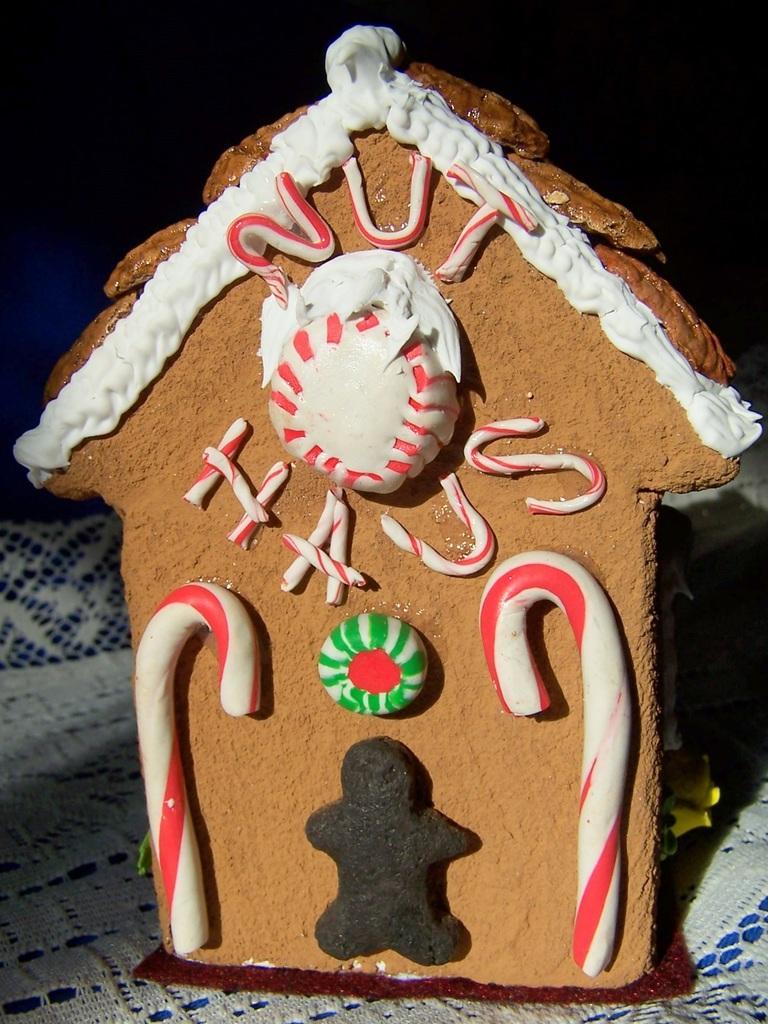Please provide a concise description of this image. Here we can see a cookie in the shape of a house. On this cookie we can see candies and there is a dark background. 